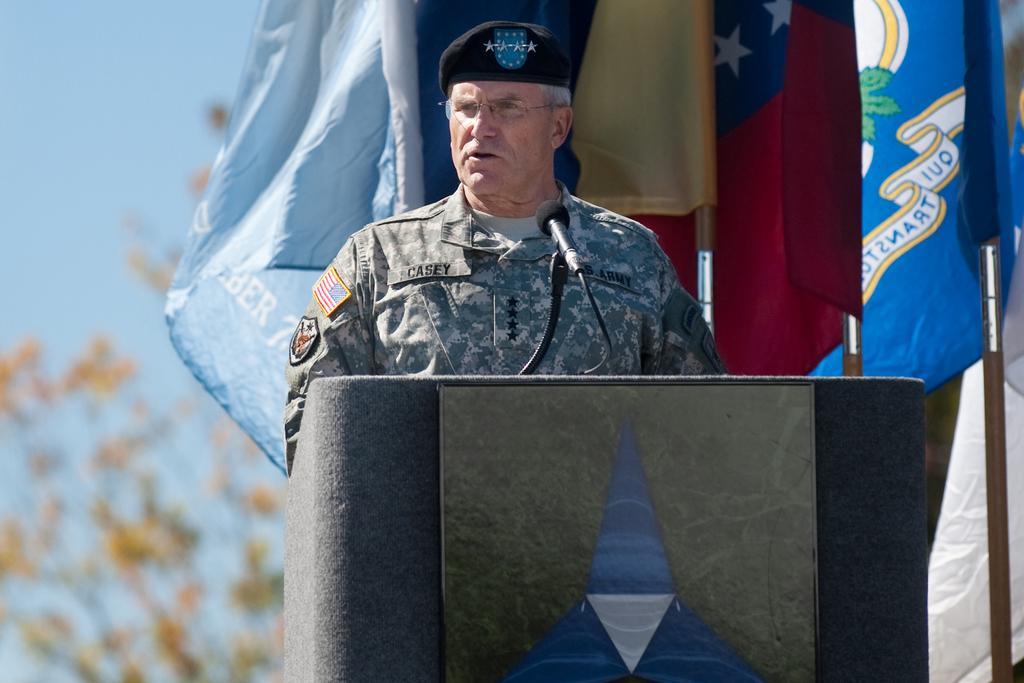Please provide a concise description of this image. In this image there is a podium with a board and mike , a person standing near the podium , flags with the poles, and in the background there is a tree, sky. 